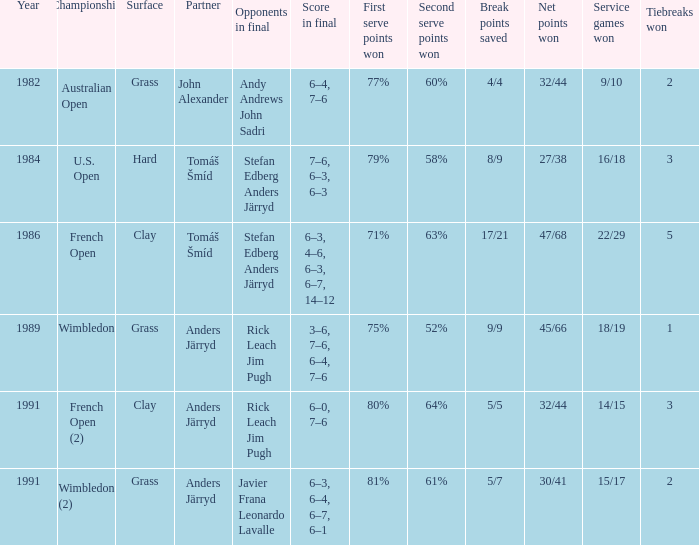Who was his partner in 1989?  Anders Järryd. 